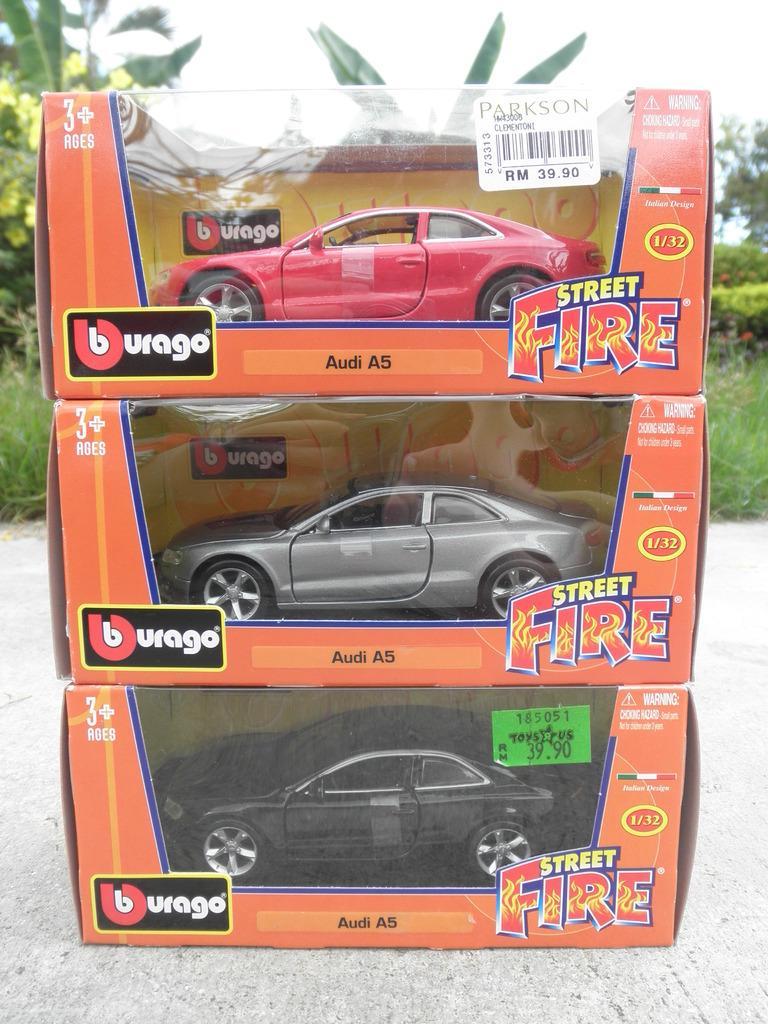Could you give a brief overview of what you see in this image? In this image, we can see toy cars in the boxes. At the bottom, we can see surface. Background we can see grass, few plants, trees and sky. On the boxes, we can see some text. Here we can see stickers. 